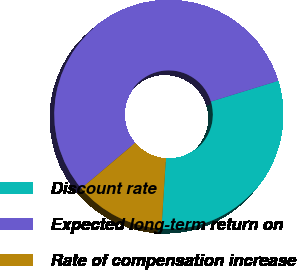Convert chart to OTSL. <chart><loc_0><loc_0><loc_500><loc_500><pie_chart><fcel>Discount rate<fcel>Expected long-term return on<fcel>Rate of compensation increase<nl><fcel>30.77%<fcel>56.41%<fcel>12.82%<nl></chart> 